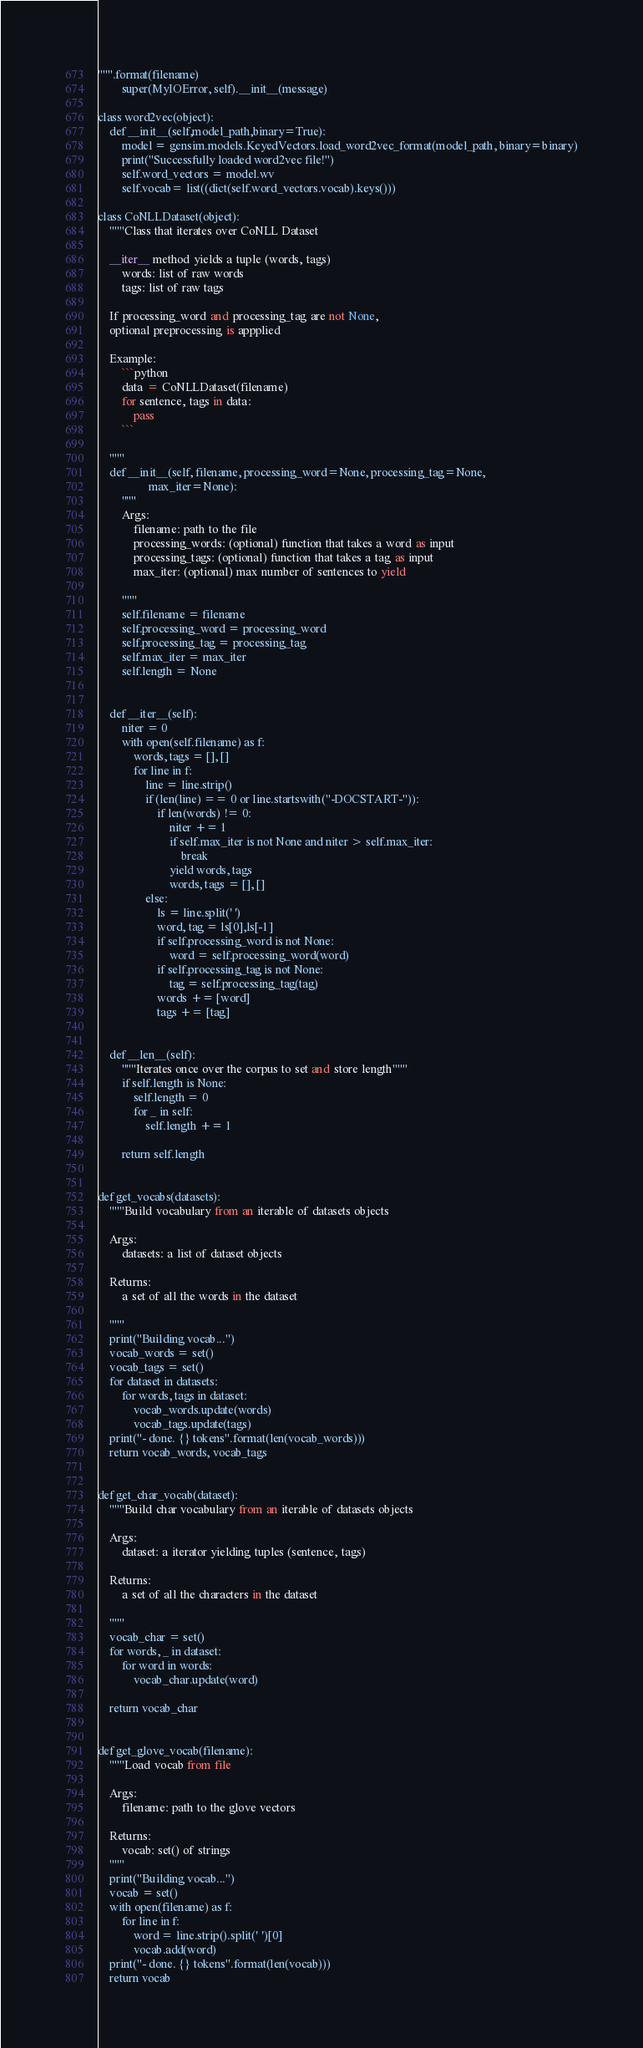<code> <loc_0><loc_0><loc_500><loc_500><_Python_>""".format(filename)
        super(MyIOError, self).__init__(message)

class word2vec(object):
    def __init__(self,model_path,binary=True):
        model = gensim.models.KeyedVectors.load_word2vec_format(model_path, binary=binary)
        print("Successfully loaded word2vec file!")
        self.word_vectors = model.wv
        self.vocab= list((dict(self.word_vectors.vocab).keys()))

class CoNLLDataset(object):
    """Class that iterates over CoNLL Dataset

    __iter__ method yields a tuple (words, tags)
        words: list of raw words
        tags: list of raw tags

    If processing_word and processing_tag are not None,
    optional preprocessing is appplied

    Example:
        ```python
        data = CoNLLDataset(filename)
        for sentence, tags in data:
            pass
        ```

    """
    def __init__(self, filename, processing_word=None, processing_tag=None,
                 max_iter=None):
        """
        Args:
            filename: path to the file
            processing_words: (optional) function that takes a word as input
            processing_tags: (optional) function that takes a tag as input
            max_iter: (optional) max number of sentences to yield

        """
        self.filename = filename
        self.processing_word = processing_word
        self.processing_tag = processing_tag
        self.max_iter = max_iter
        self.length = None


    def __iter__(self):
        niter = 0
        with open(self.filename) as f:
            words, tags = [], []
            for line in f:
                line = line.strip()
                if (len(line) == 0 or line.startswith("-DOCSTART-")):
                    if len(words) != 0:
                        niter += 1
                        if self.max_iter is not None and niter > self.max_iter:
                            break
                        yield words, tags
                        words, tags = [], []
                else:
                    ls = line.split(' ')
                    word, tag = ls[0],ls[-1]
                    if self.processing_word is not None:
                        word = self.processing_word(word)
                    if self.processing_tag is not None:
                        tag = self.processing_tag(tag)
                    words += [word]
                    tags += [tag]


    def __len__(self):
        """Iterates once over the corpus to set and store length"""
        if self.length is None:
            self.length = 0
            for _ in self:
                self.length += 1

        return self.length


def get_vocabs(datasets):
    """Build vocabulary from an iterable of datasets objects

    Args:
        datasets: a list of dataset objects

    Returns:
        a set of all the words in the dataset

    """
    print("Building vocab...")
    vocab_words = set()
    vocab_tags = set()
    for dataset in datasets:
        for words, tags in dataset:
            vocab_words.update(words)
            vocab_tags.update(tags)
    print("- done. {} tokens".format(len(vocab_words)))
    return vocab_words, vocab_tags


def get_char_vocab(dataset):
    """Build char vocabulary from an iterable of datasets objects

    Args:
        dataset: a iterator yielding tuples (sentence, tags)

    Returns:
        a set of all the characters in the dataset

    """
    vocab_char = set()
    for words, _ in dataset:
        for word in words:
            vocab_char.update(word)

    return vocab_char


def get_glove_vocab(filename):
    """Load vocab from file

    Args:
        filename: path to the glove vectors

    Returns:
        vocab: set() of strings
    """
    print("Building vocab...")
    vocab = set()
    with open(filename) as f:
        for line in f:
            word = line.strip().split(' ')[0]
            vocab.add(word)
    print("- done. {} tokens".format(len(vocab)))
    return vocab

</code> 